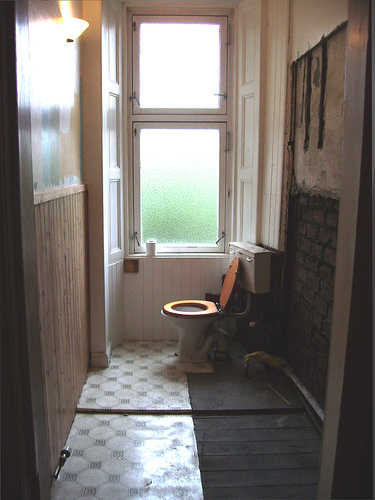<image>What is the robe made out of? There is no robe in the image. What is the robe made out of? It is unanswerable what the robe is made out of. 